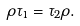Convert formula to latex. <formula><loc_0><loc_0><loc_500><loc_500>\rho \tau _ { 1 } = \tau _ { 2 } \rho .</formula> 